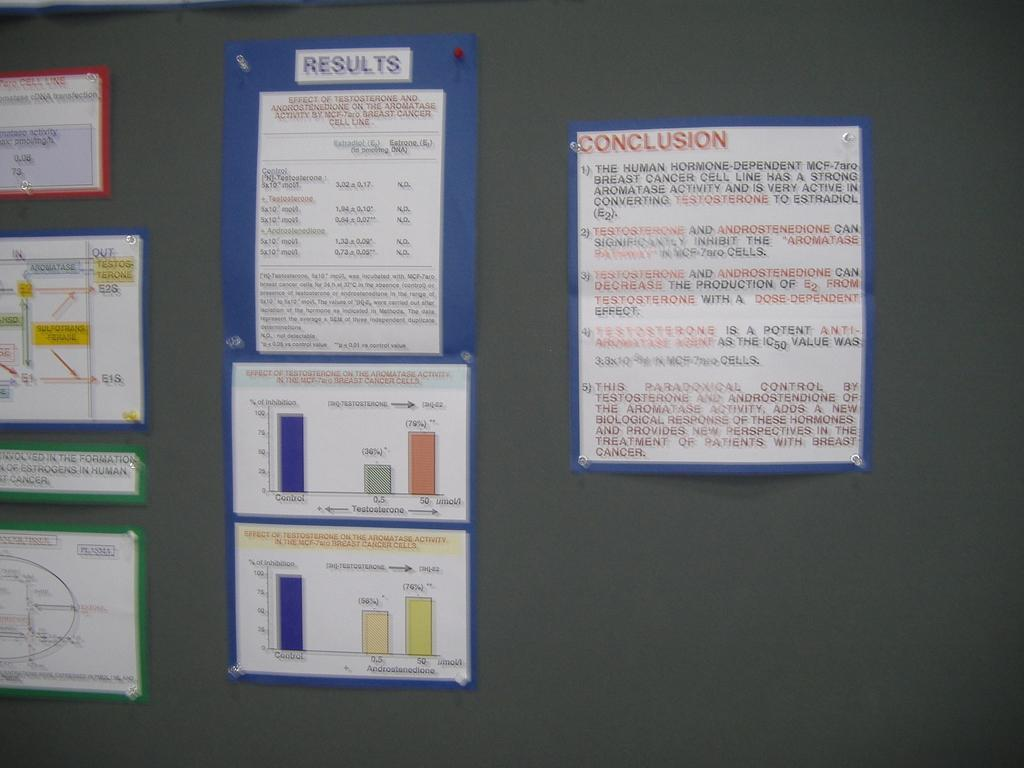<image>
Provide a brief description of the given image. A corkboard has research for the Results of testosterone on breast cancer as well as the conclusion of the research. 